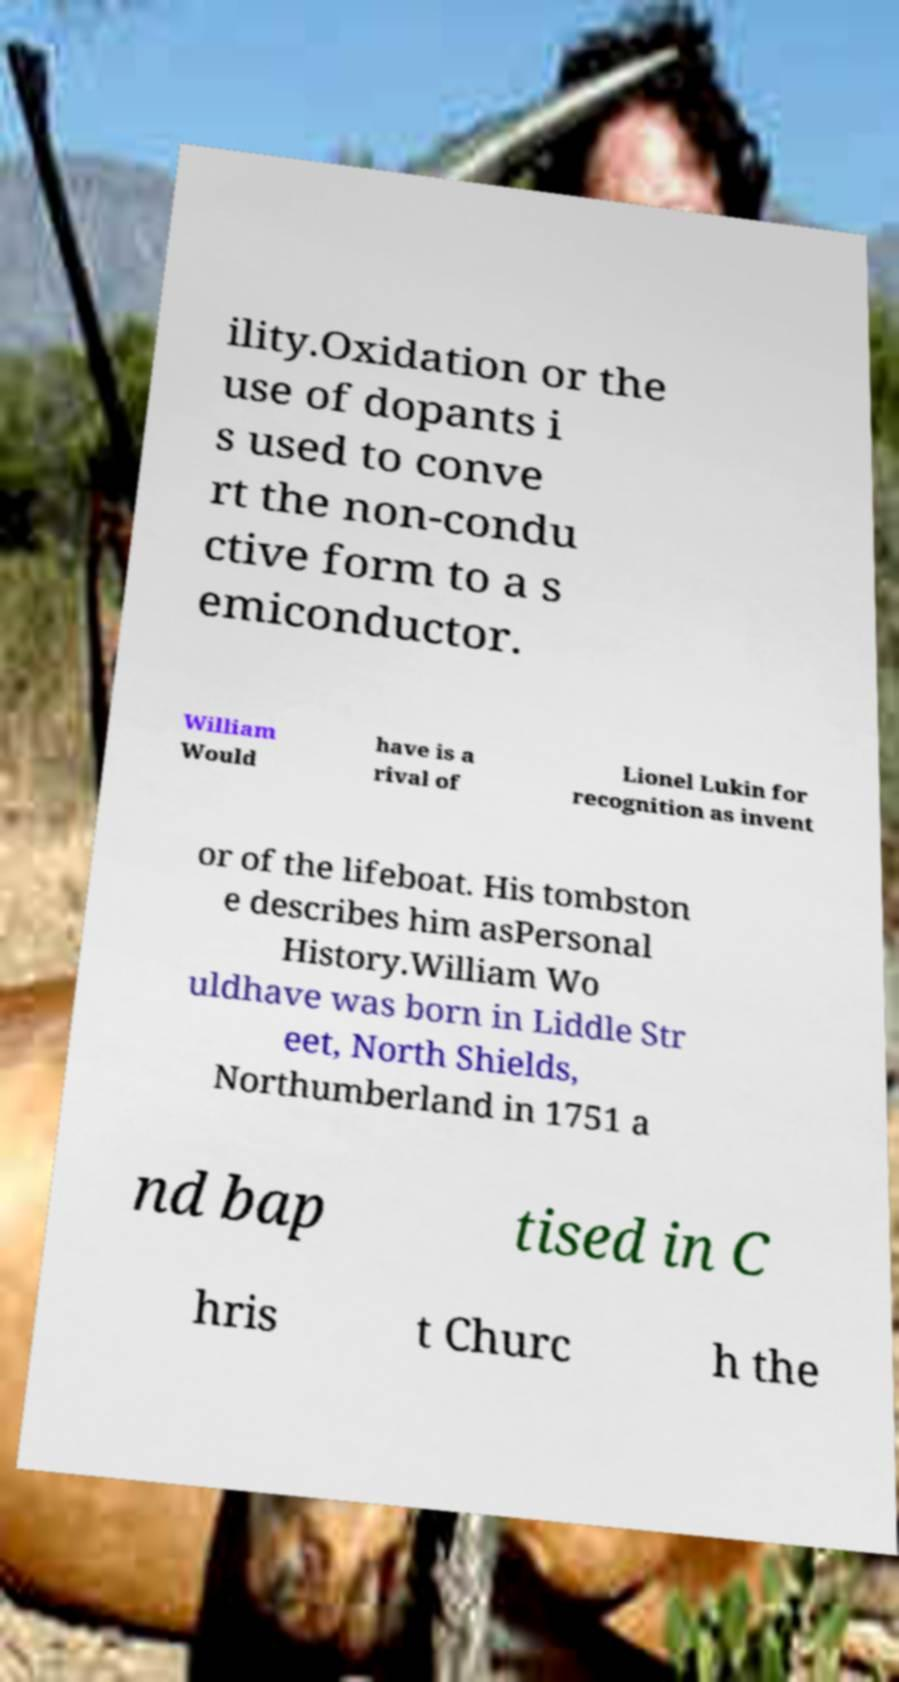There's text embedded in this image that I need extracted. Can you transcribe it verbatim? ility.Oxidation or the use of dopants i s used to conve rt the non-condu ctive form to a s emiconductor. William Would have is a rival of Lionel Lukin for recognition as invent or of the lifeboat. His tombston e describes him asPersonal History.William Wo uldhave was born in Liddle Str eet, North Shields, Northumberland in 1751 a nd bap tised in C hris t Churc h the 